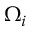<formula> <loc_0><loc_0><loc_500><loc_500>\Omega _ { i }</formula> 